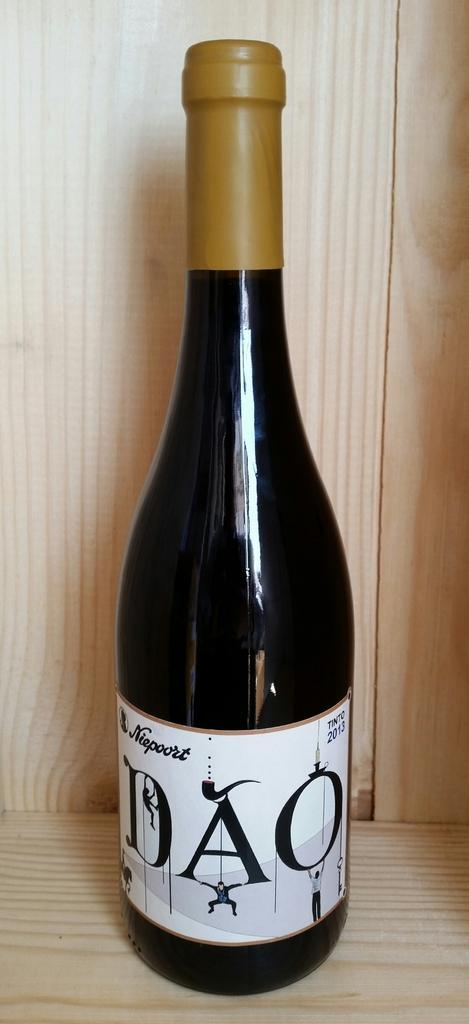Provide a one-sentence caption for the provided image. A 2013, DAO bottle of wine is sitting on a counter. 